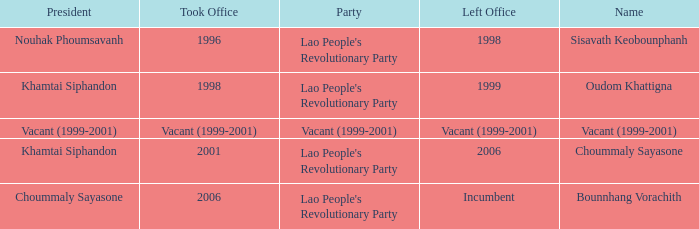Could you parse the entire table as a dict? {'header': ['President', 'Took Office', 'Party', 'Left Office', 'Name'], 'rows': [['Nouhak Phoumsavanh', '1996', "Lao People's Revolutionary Party", '1998', 'Sisavath Keobounphanh'], ['Khamtai Siphandon', '1998', "Lao People's Revolutionary Party", '1999', 'Oudom Khattigna'], ['Vacant (1999-2001)', 'Vacant (1999-2001)', 'Vacant (1999-2001)', 'Vacant (1999-2001)', 'Vacant (1999-2001)'], ['Khamtai Siphandon', '2001', "Lao People's Revolutionary Party", '2006', 'Choummaly Sayasone'], ['Choummaly Sayasone', '2006', "Lao People's Revolutionary Party", 'Incumbent', 'Bounnhang Vorachith']]} What is Name, when President is Khamtai Siphandon, and when Left Office is 1999? Oudom Khattigna. 